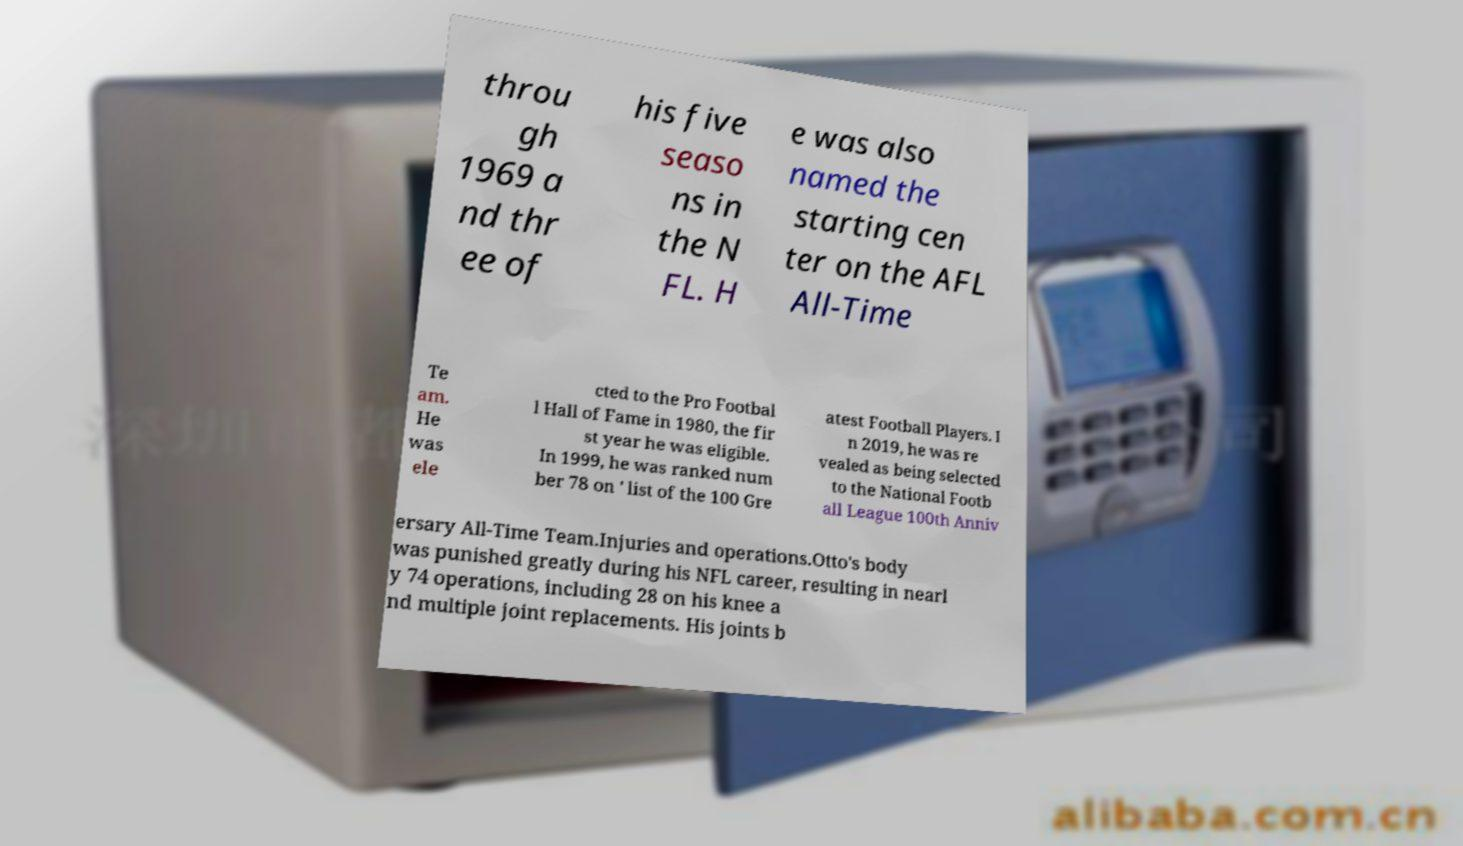For documentation purposes, I need the text within this image transcribed. Could you provide that? throu gh 1969 a nd thr ee of his five seaso ns in the N FL. H e was also named the starting cen ter on the AFL All-Time Te am. He was ele cted to the Pro Footbal l Hall of Fame in 1980, the fir st year he was eligible. In 1999, he was ranked num ber 78 on ' list of the 100 Gre atest Football Players. I n 2019, he was re vealed as being selected to the National Footb all League 100th Anniv ersary All-Time Team.Injuries and operations.Otto's body was punished greatly during his NFL career, resulting in nearl y 74 operations, including 28 on his knee a nd multiple joint replacements. His joints b 